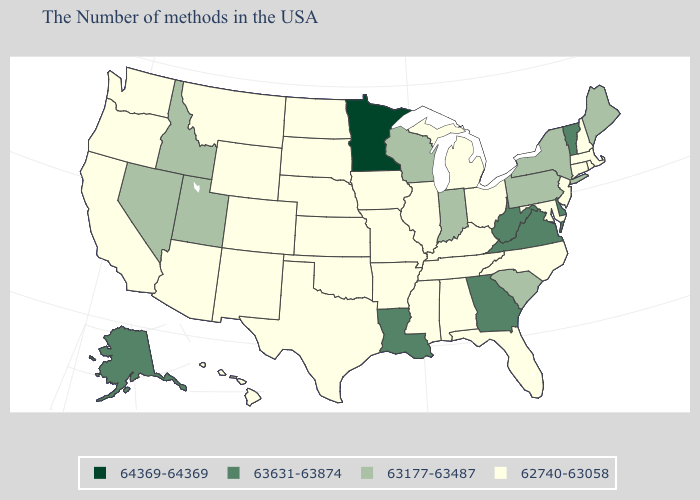What is the value of Virginia?
Be succinct. 63631-63874. Does the first symbol in the legend represent the smallest category?
Answer briefly. No. Does West Virginia have the lowest value in the USA?
Be succinct. No. How many symbols are there in the legend?
Answer briefly. 4. What is the lowest value in the USA?
Concise answer only. 62740-63058. What is the value of Iowa?
Answer briefly. 62740-63058. What is the lowest value in states that border Montana?
Short answer required. 62740-63058. Does the first symbol in the legend represent the smallest category?
Write a very short answer. No. What is the highest value in the USA?
Be succinct. 64369-64369. Name the states that have a value in the range 63631-63874?
Be succinct. Vermont, Delaware, Virginia, West Virginia, Georgia, Louisiana, Alaska. Name the states that have a value in the range 63177-63487?
Short answer required. Maine, New York, Pennsylvania, South Carolina, Indiana, Wisconsin, Utah, Idaho, Nevada. Does New Jersey have the lowest value in the USA?
Concise answer only. Yes. Which states have the lowest value in the MidWest?
Concise answer only. Ohio, Michigan, Illinois, Missouri, Iowa, Kansas, Nebraska, South Dakota, North Dakota. Name the states that have a value in the range 63177-63487?
Write a very short answer. Maine, New York, Pennsylvania, South Carolina, Indiana, Wisconsin, Utah, Idaho, Nevada. What is the lowest value in the USA?
Short answer required. 62740-63058. 